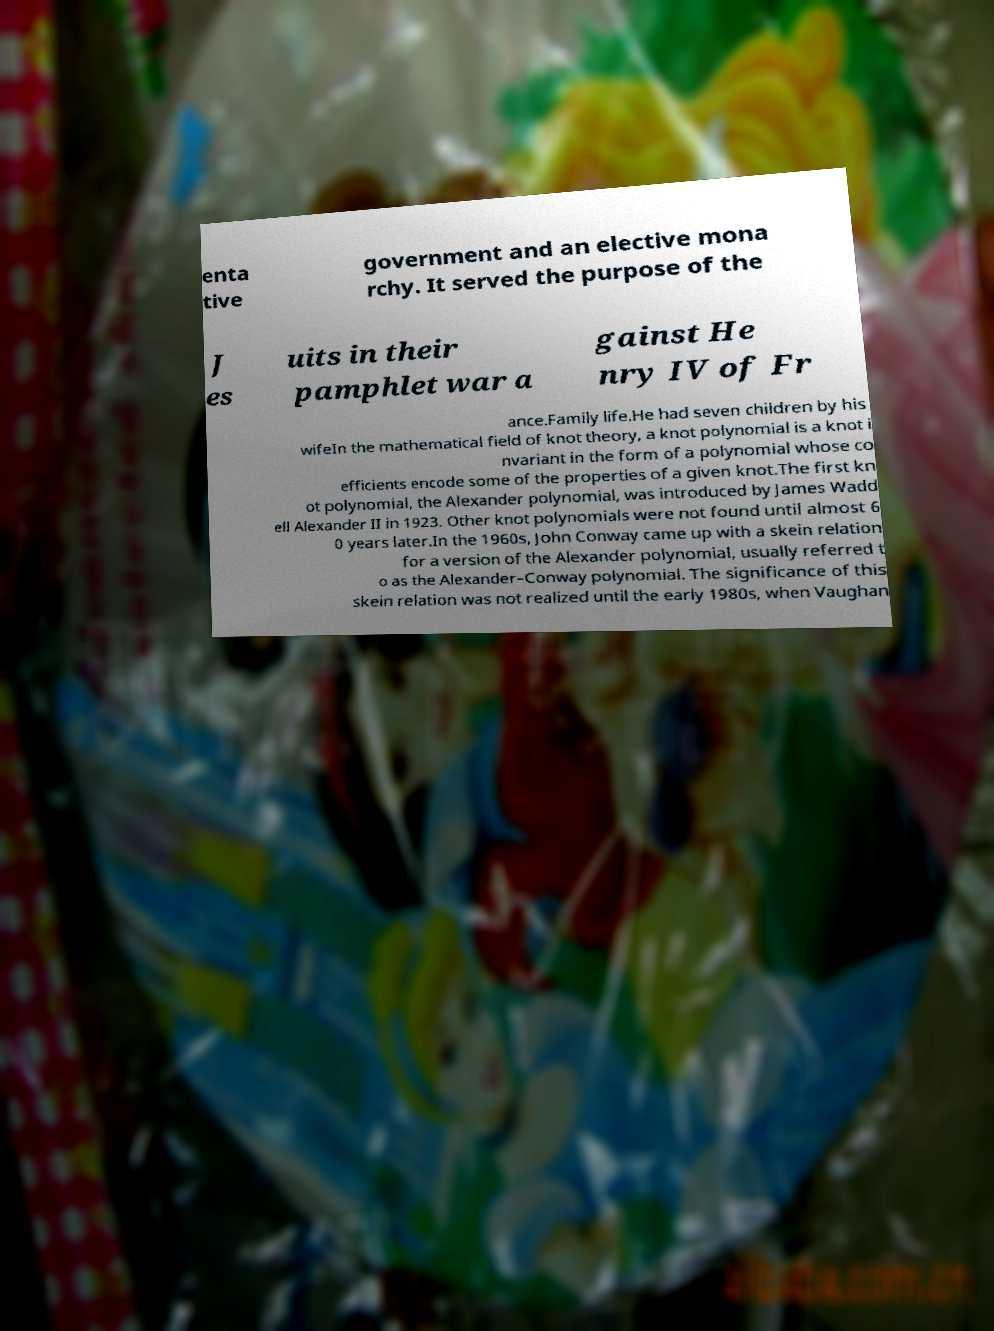Please read and relay the text visible in this image. What does it say? enta tive government and an elective mona rchy. It served the purpose of the J es uits in their pamphlet war a gainst He nry IV of Fr ance.Family life.He had seven children by his wifeIn the mathematical field of knot theory, a knot polynomial is a knot i nvariant in the form of a polynomial whose co efficients encode some of the properties of a given knot.The first kn ot polynomial, the Alexander polynomial, was introduced by James Wadd ell Alexander II in 1923. Other knot polynomials were not found until almost 6 0 years later.In the 1960s, John Conway came up with a skein relation for a version of the Alexander polynomial, usually referred t o as the Alexander–Conway polynomial. The significance of this skein relation was not realized until the early 1980s, when Vaughan 